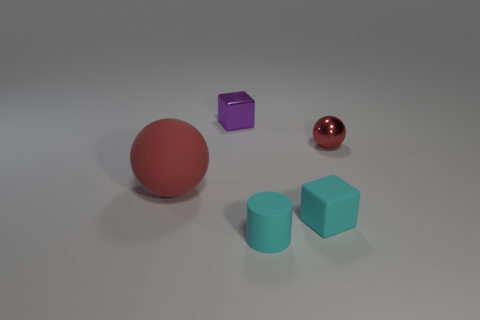Subtract all gray cylinders. Subtract all cyan spheres. How many cylinders are left? 1 Add 3 tiny cyan cubes. How many objects exist? 8 Subtract all spheres. How many objects are left? 3 Add 4 small cylinders. How many small cylinders exist? 5 Subtract 0 green cubes. How many objects are left? 5 Subtract all tiny green rubber spheres. Subtract all tiny cyan matte cylinders. How many objects are left? 4 Add 2 metal balls. How many metal balls are left? 3 